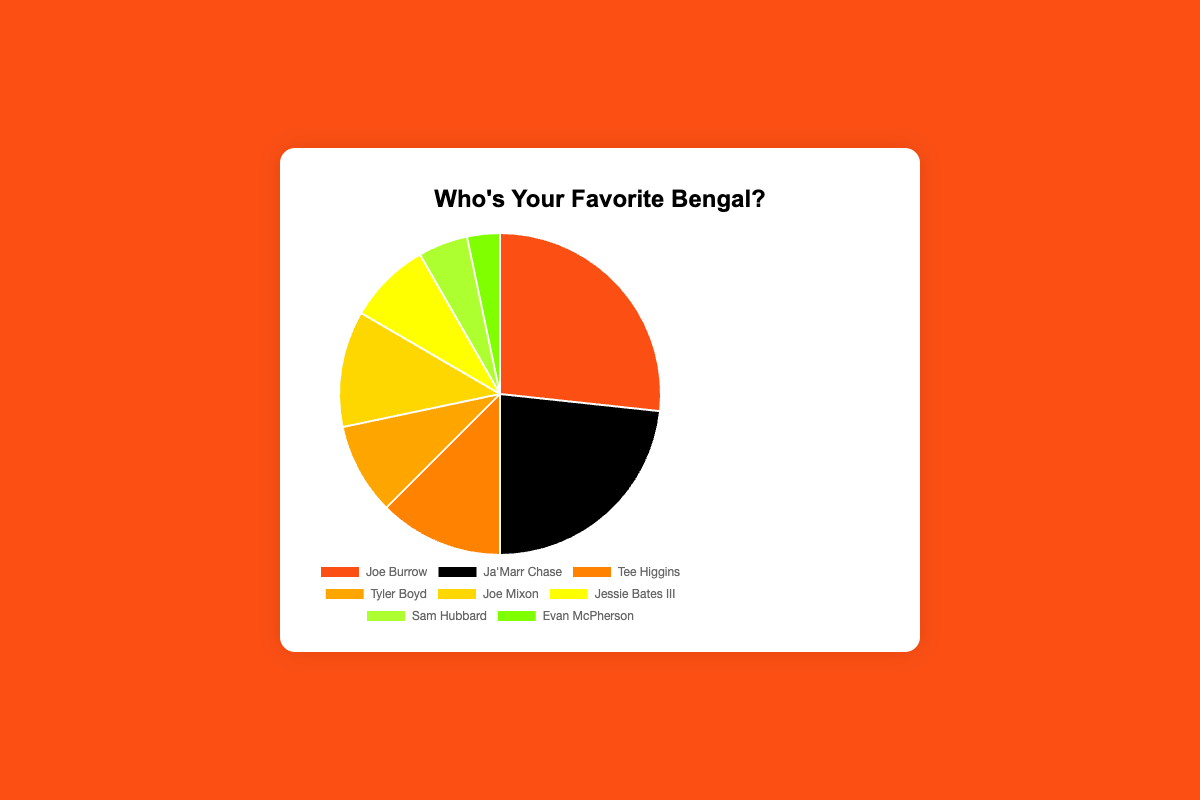What percentage of votes did Joe Burrow receive? Joe Burrow received 26.7% of the votes according to the data provided.
Answer: 26.7% How many more votes did Joe Burrow get compared to Evan McPherson? Joe Burrow received 320 votes, while Evan McPherson received 40 votes. The difference between them is 320 - 40 = 280 votes.
Answer: 280 Which player received the second highest percentage of votes? Ja'Marr Chase received the second highest percentage of votes, totaling 23.3%.
Answer: Ja'Marr Chase What is the sum of the percentage of votes received by Tyler Boyd and Tee Higgins? Tyler Boyd received 9.2% and Tee Higgins received 12.5%, so the total is 9.2% + 12.5% = 21.7%.
Answer: 21.7% How many players received less than 10% of the votes? Tyler Boyd (9.2%), Jessie Bates III (8.3%), Sam Hubbard (5.0%), and Evan McPherson (3.3%) received less than 10%. There are 4 players in total.
Answer: 4 Which player received the fewest number of votes, and what percentage did they receive? Evan McPherson received the fewest votes with 40 votes, which is 3.3% of the total.
Answer: Evan McPherson, 3.3% If you combine the votes of Joe Mixon and Tee Higgins, what percentage of the total votes do they account for? Joe Mixon received 11.7% of the votes, and Tee Higgins received 12.5%. Combined, they account for 11.7% + 12.5% = 24.2%.
Answer: 24.2% Which two players together received just over half of the total votes? Joe Burrow received 26.7% and Ja'Marr Chase received 23.3%. Together, they received 26.7% + 23.3% = 50%, just around half of the total votes.
Answer: Joe Burrow and Ja'Marr Chase What is the difference in the percentage of votes between the player with the third highest votes and the player with the lowest votes? Tee Higgins has the third highest percentage of votes with 12.5%. Evan McPherson has the lowest at 3.3%. The difference is 12.5% - 3.3% = 9.2%.
Answer: 9.2% 